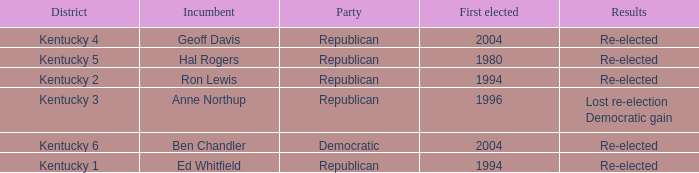In what year was the republican incumbent from Kentucky 2 district first elected? 1994.0. Could you parse the entire table as a dict? {'header': ['District', 'Incumbent', 'Party', 'First elected', 'Results'], 'rows': [['Kentucky 4', 'Geoff Davis', 'Republican', '2004', 'Re-elected'], ['Kentucky 5', 'Hal Rogers', 'Republican', '1980', 'Re-elected'], ['Kentucky 2', 'Ron Lewis', 'Republican', '1994', 'Re-elected'], ['Kentucky 3', 'Anne Northup', 'Republican', '1996', 'Lost re-election Democratic gain'], ['Kentucky 6', 'Ben Chandler', 'Democratic', '2004', 'Re-elected'], ['Kentucky 1', 'Ed Whitfield', 'Republican', '1994', 'Re-elected']]} 